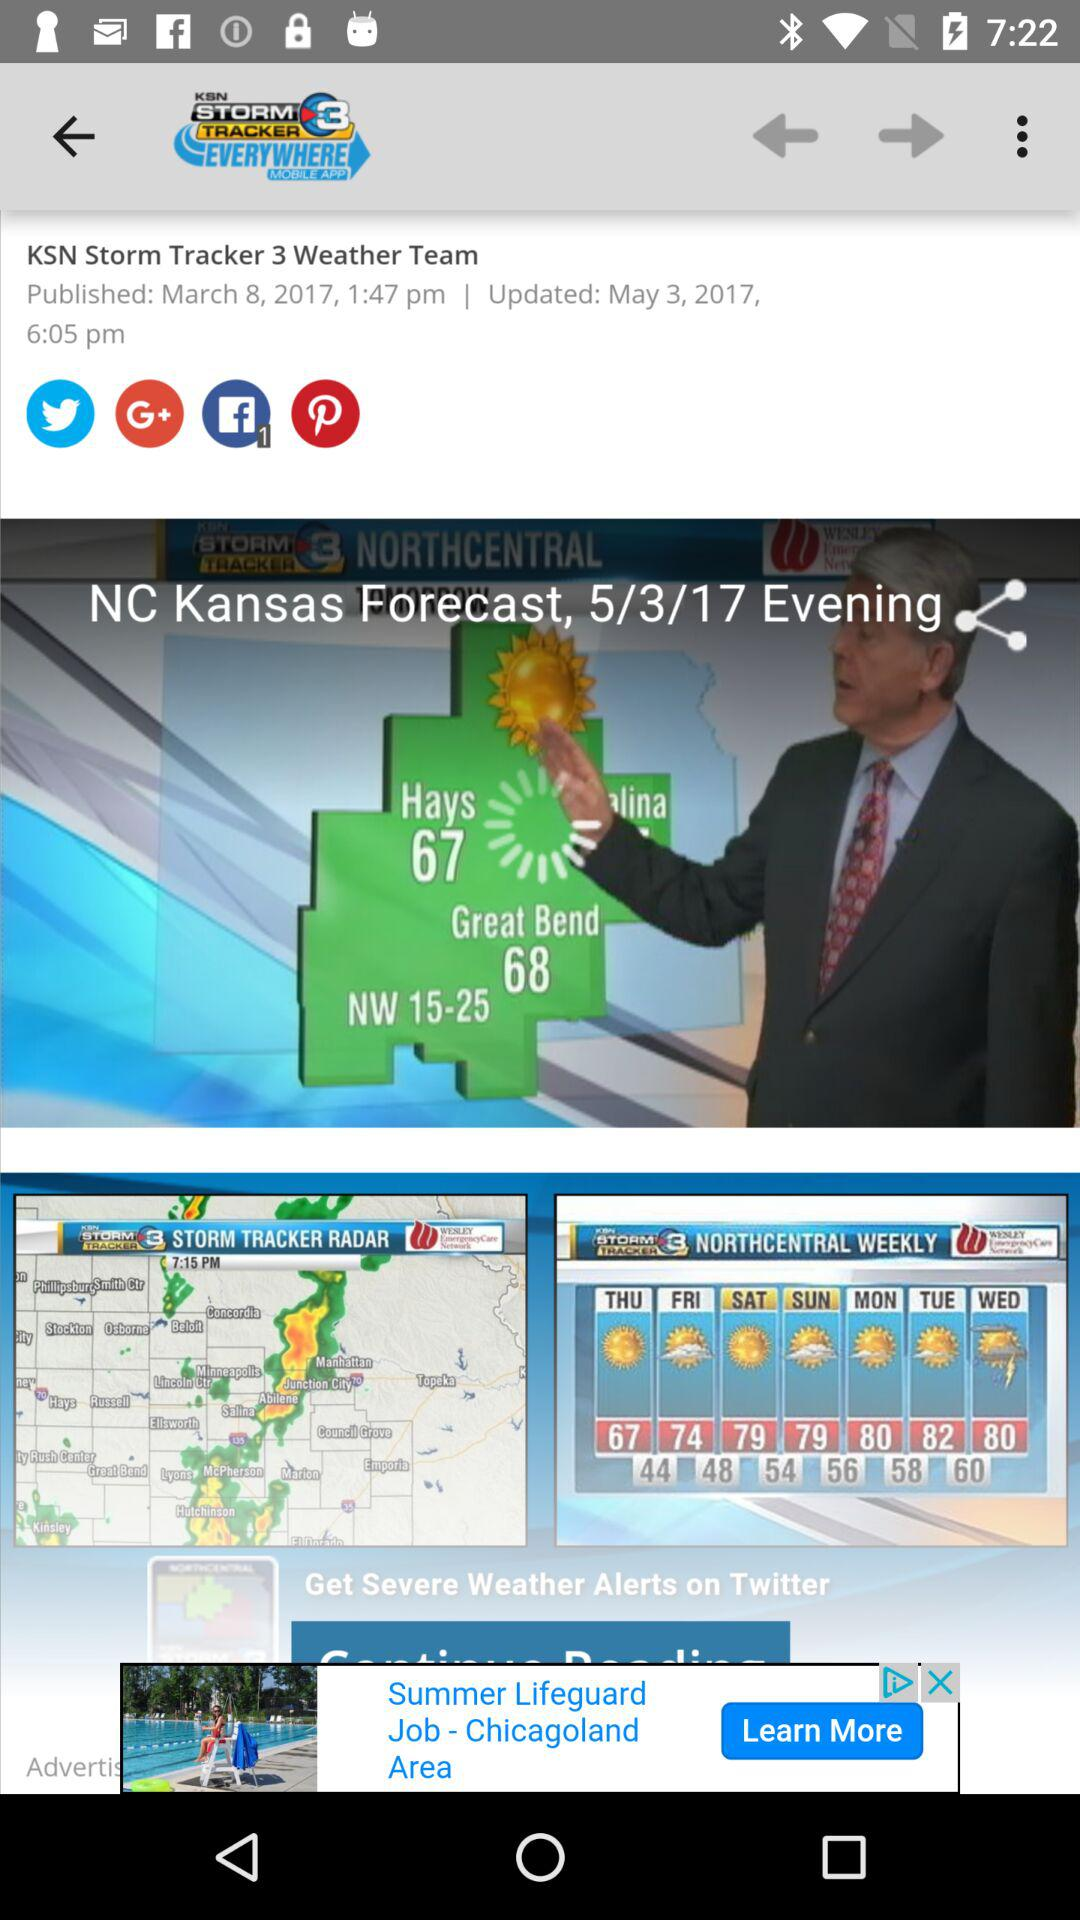What's the published date? The published date is March 8, 2017. 